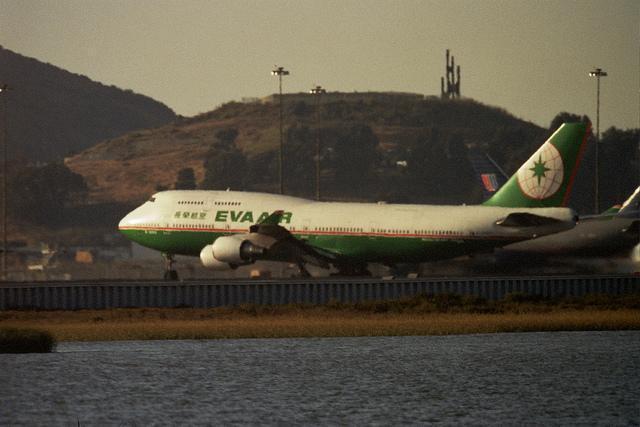How many light poles are in the photo?
Give a very brief answer. 2. How many polar bears are there?
Give a very brief answer. 0. 